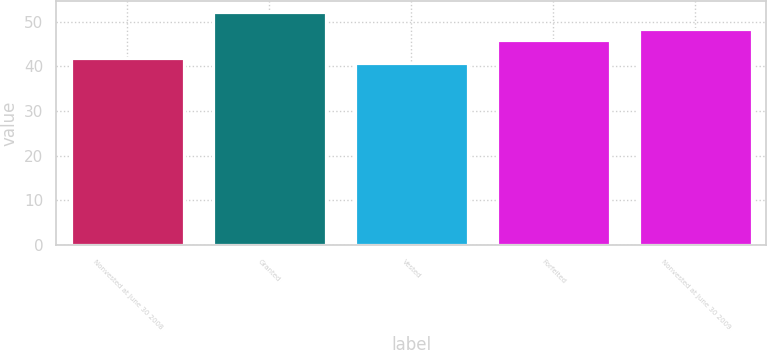Convert chart. <chart><loc_0><loc_0><loc_500><loc_500><bar_chart><fcel>Nonvested at June 30 2008<fcel>Granted<fcel>Vested<fcel>Forfeited<fcel>Nonvested at June 30 2009<nl><fcel>41.86<fcel>52.13<fcel>40.72<fcel>45.98<fcel>48.31<nl></chart> 